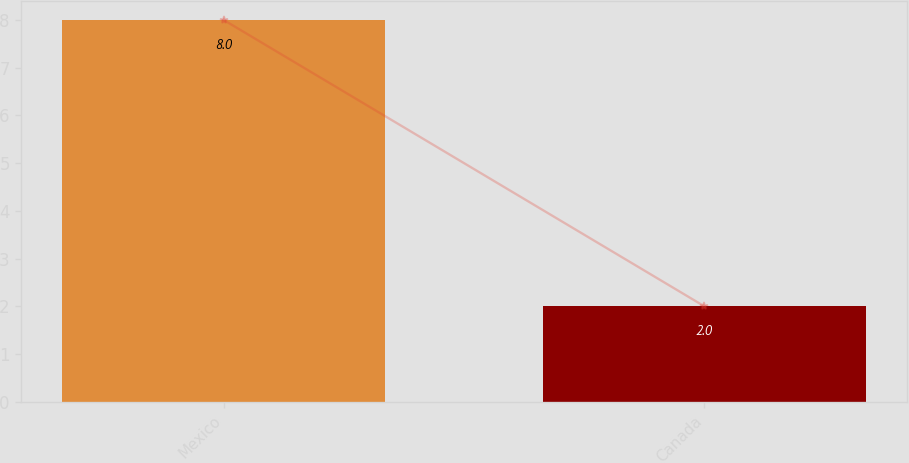Convert chart to OTSL. <chart><loc_0><loc_0><loc_500><loc_500><bar_chart><fcel>Mexico<fcel>Canada<nl><fcel>8<fcel>2<nl></chart> 